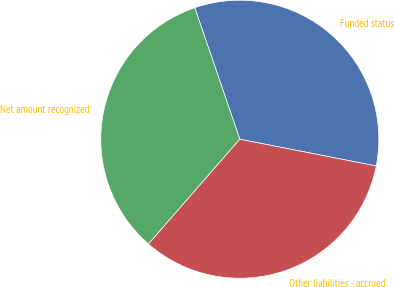Convert chart. <chart><loc_0><loc_0><loc_500><loc_500><pie_chart><fcel>Funded status<fcel>Net amount recognized<fcel>Other liabilities - accrued<nl><fcel>33.33%<fcel>33.33%<fcel>33.33%<nl></chart> 